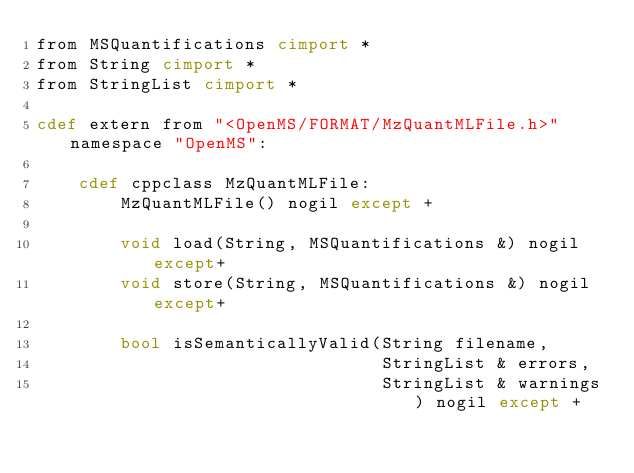<code> <loc_0><loc_0><loc_500><loc_500><_Cython_>from MSQuantifications cimport *
from String cimport *
from StringList cimport *

cdef extern from "<OpenMS/FORMAT/MzQuantMLFile.h>" namespace "OpenMS":

    cdef cppclass MzQuantMLFile:
        MzQuantMLFile() nogil except +

        void load(String, MSQuantifications &) nogil except+
        void store(String, MSQuantifications &) nogil except+

        bool isSemanticallyValid(String filename,
                                 StringList & errors,
                                 StringList & warnings) nogil except +


</code> 